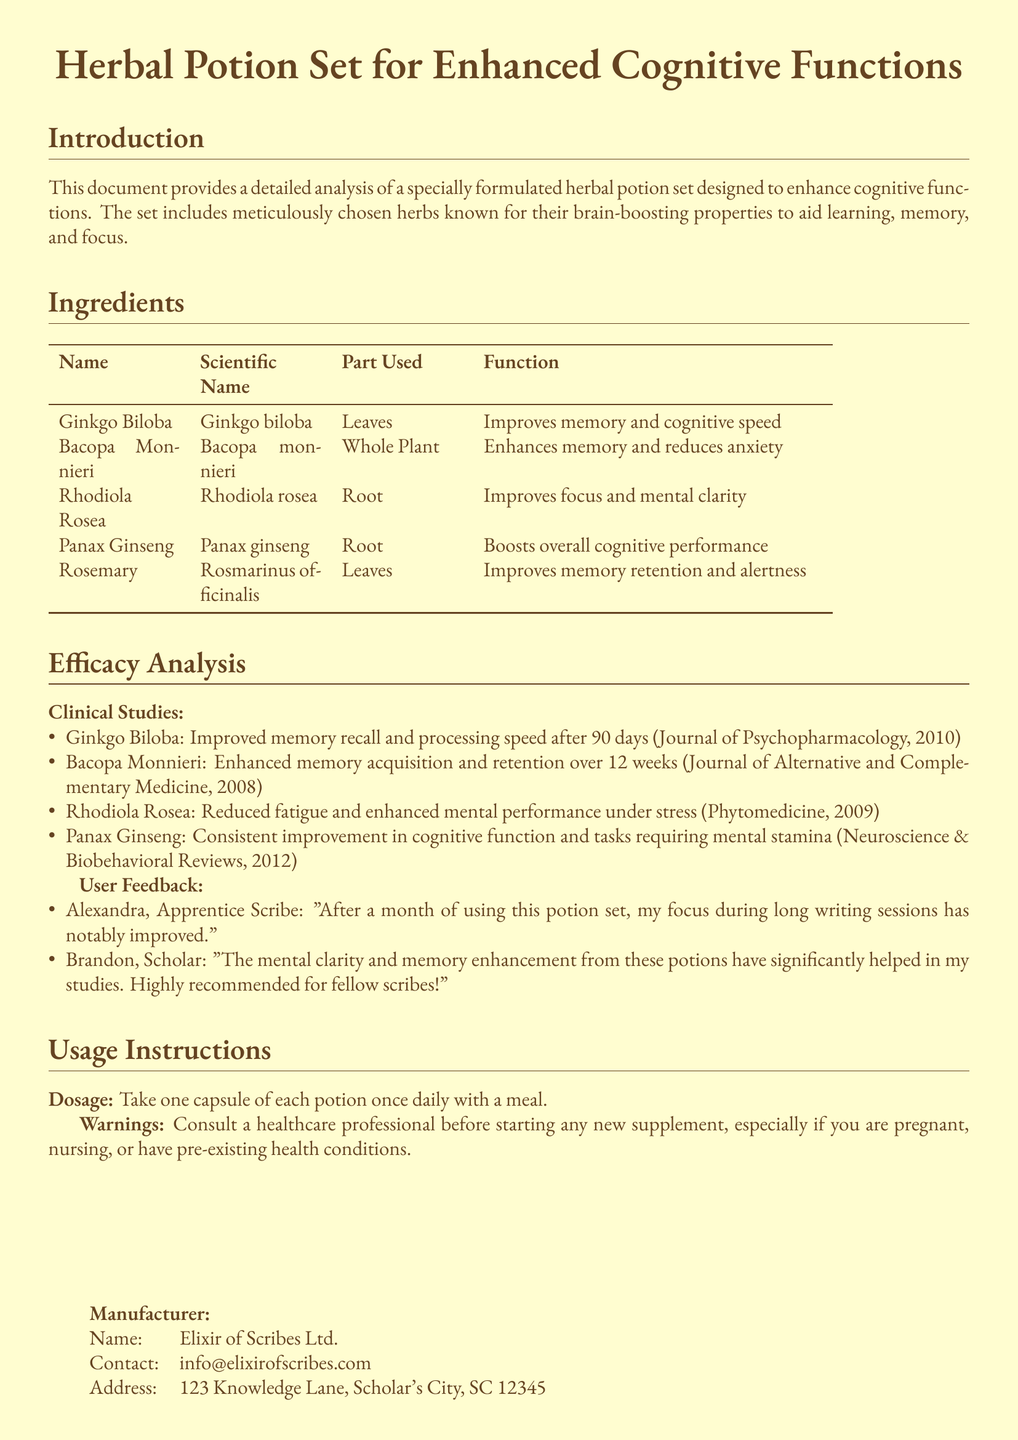What is the purpose of the potion set? The purpose is to enhance cognitive functions, specifically aiding learning, memory, and focus.
Answer: Enhance cognitive functions Which herb is known for improving memory retention? Rosemary is specifically mentioned for improving memory retention and alertness.
Answer: Rosemary How long was Ginkgo Biloba studied for its effects? The study measured effects over a duration of 90 days.
Answer: 90 days What part of Bacopa Monnieri is used in the potion? The whole plant is used as the part of Bacopa Monnieri in the potion.
Answer: Whole Plant What is the recommended dosage for the potion set? The recommended dosage is one capsule of each potion taken once daily with a meal.
Answer: One capsule of each potion once daily Who is the manufacturer of the potion set? The manufacturer is Elixir of Scribes Ltd.
Answer: Elixir of Scribes Ltd Which clinical study pertains to Rhodiola Rosea? The clinical study indicates reduced fatigue and enhanced mental performance under stress.
Answer: Reduced fatigue and enhanced mental performance under stress How many user feedback comments are included in the document? There are two user feedback comments included in the document.
Answer: Two 